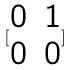Convert formula to latex. <formula><loc_0><loc_0><loc_500><loc_500>[ \begin{matrix} 0 & 1 \\ 0 & 0 \end{matrix} ]</formula> 